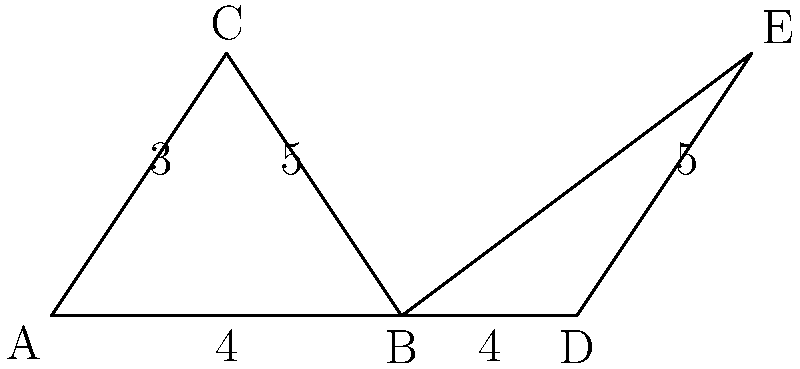Hey there, fellow artist! I've sketched out two triangles for you. Triangle ABC has sides of length 3, 4, and 5, with a right angle at B. Triangle BDE also has a right angle at B and shares the side of length 4 with triangle ABC. If the angle at B in both triangles is 37°, are these triangles congruent? If so, which congruence criterion applies? Let's approach this step-by-step:

1) First, let's identify what we know about each triangle:

   Triangle ABC:
   - Right angle at B
   - Angle at B is 37°
   - Side lengths: 3, 4, and 5

   Triangle BDE:
   - Right angle at B
   - Angle at B is 37°
   - One side length (BD) is 4

2) Now, let's consider the congruence criteria:
   - SSS (Side-Side-Side)
   - SAS (Side-Angle-Side)
   - ASA (Angle-Side-Angle)
   - AAS (Angle-Angle-Side)
   - HL (Hypotenuse-Leg)

3) We can see that both triangles share:
   - A right angle at B (90°)
   - An angle of 37° at B
   - A side of length 4 adjacent to both these angles

4) This information fits the AAS (Angle-Angle-Side) criterion:
   - We have two angles (37° and 90°)
   - We have a side (length 4) adjacent to both these angles

5) According to the AAS criterion, if two angles and the non-included side of one triangle are equal to the corresponding parts of another triangle, the triangles are congruent.

6) Therefore, we can conclude that triangles ABC and BDE are congruent.
Answer: Yes, congruent by AAS 